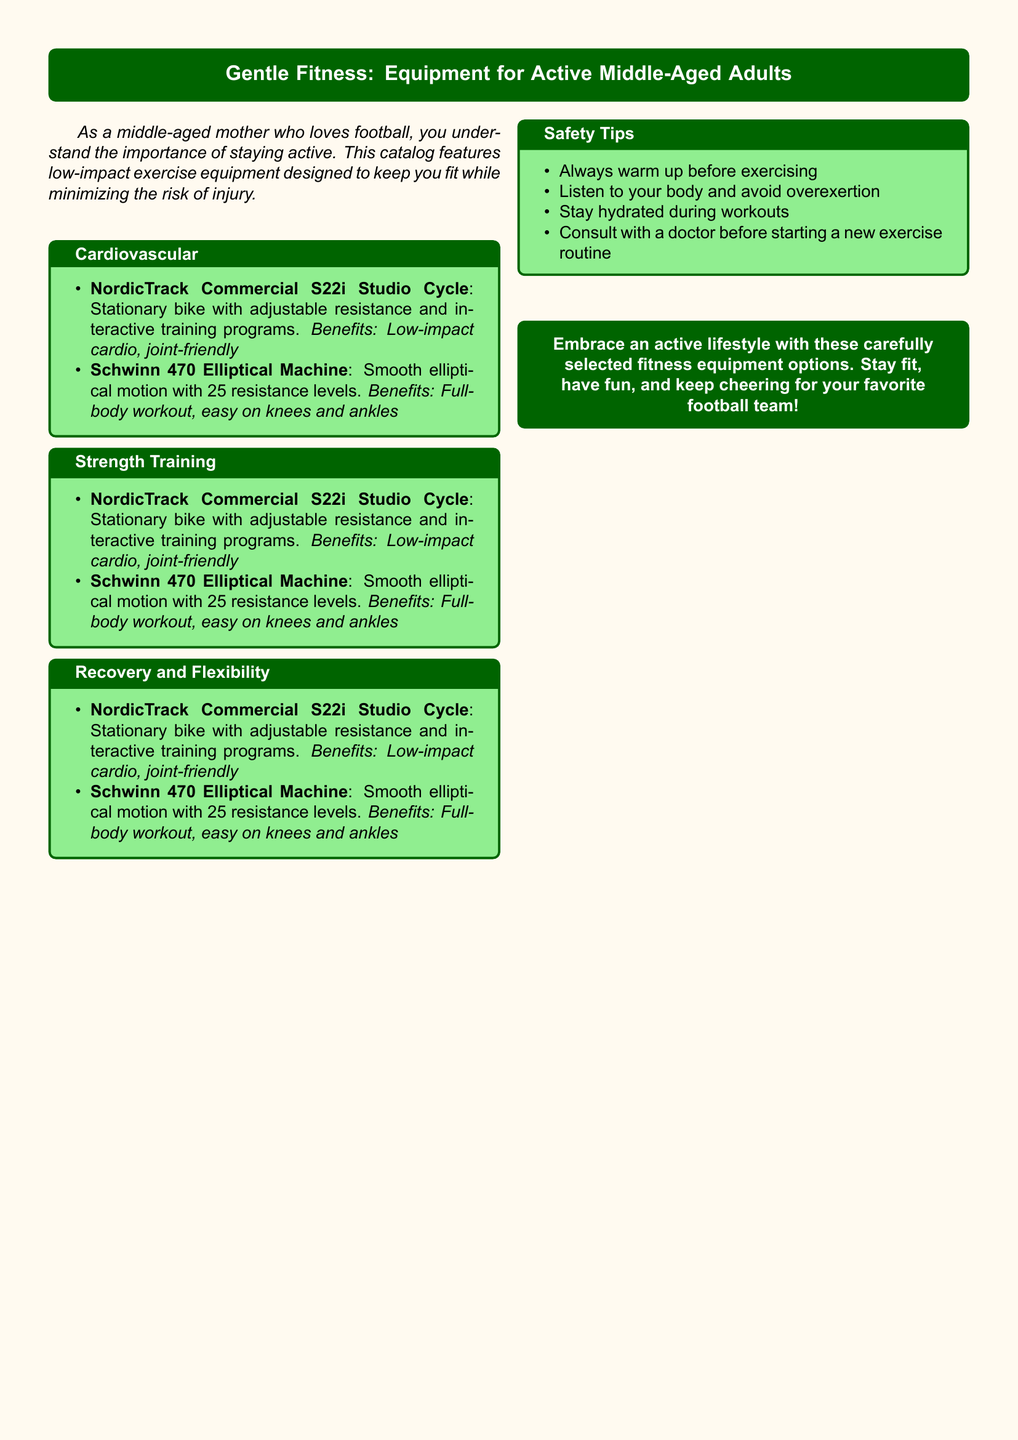What is the title of the catalog? The title of the catalog is presented in a bold tcolorbox at the center of the document.
Answer: Gentle Fitness: Equipment for Active Middle-Aged Adults What type of exercise equipment is the NordicTrack Commercial S22i? The document specifies the type of exercise equipment using simple descriptions.
Answer: Stationary bike How many resistance levels does the Schwinn 470 Elliptical Machine have? This number is explicitly stated in the description of the product in the catalog.
Answer: 25 What is one of the benefits of the NordicTrack Commercial S22i? The document highlights specific benefits of each exercise equipment to emphasize their features.
Answer: Low-impact cardio What should you do before starting a new exercise routine? This is listed among safety tips to ensure safe exercise practices for middle-aged adults.
Answer: Consult with a doctor Which equipment provides a full-body workout? The equipment offering a comprehensive workout is mentioned in the corresponding section.
Answer: Schwinn 470 Elliptical Machine What color is the background of the document? The document includes specific color choices in its design, including background colors.
Answer: Light beige What should you do during workouts according to the safety tips? The safety tips include advice on maintaining hydration while exercising.
Answer: Stay hydrated 